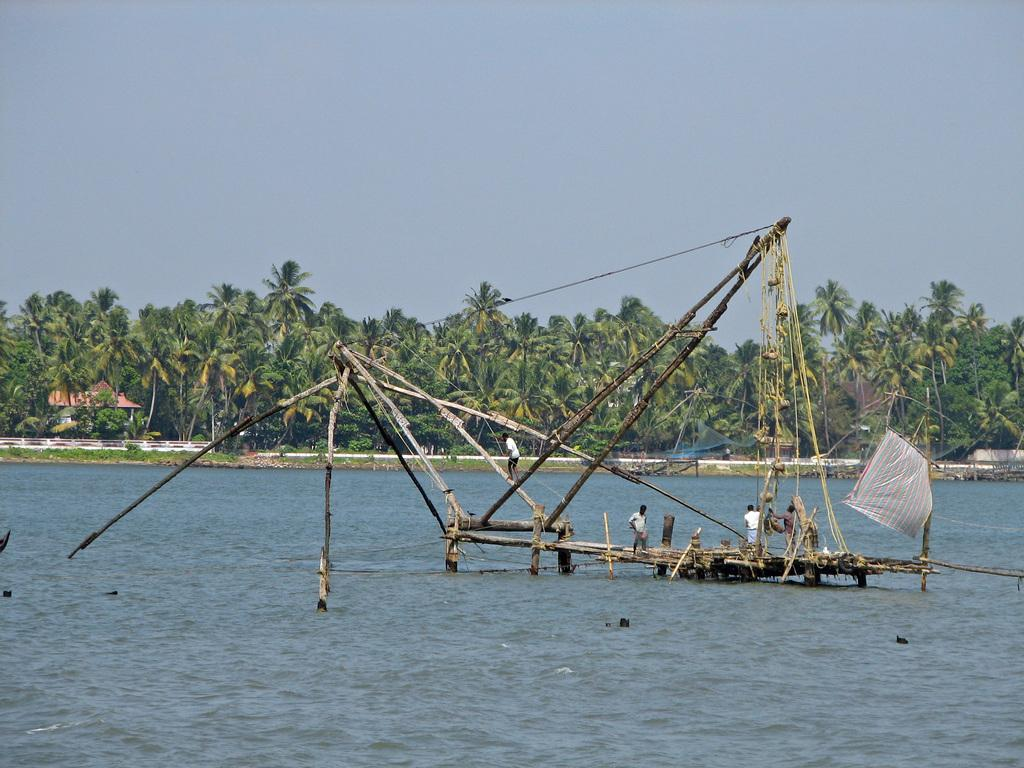What are the persons in the image doing? The persons in the image are fishing. Where are the persons located in the image? The persons are on the woods in the image. What can be seen in the background of the image? There is a shelter and trees in the background of the image, and the sky is blue. Can you see a monkey holding a jar of eggs in the image? No, there is no monkey, jar, or eggs present in the image. 